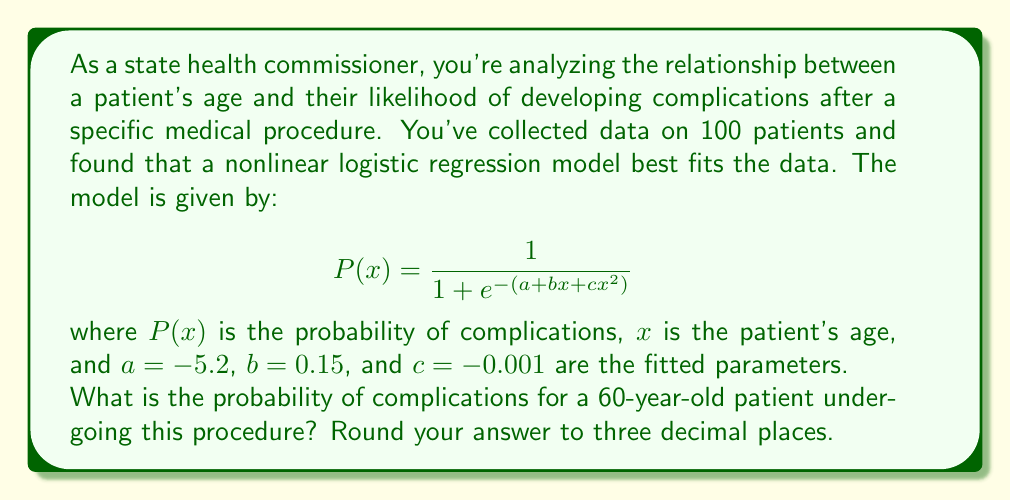Help me with this question. To solve this problem, we need to follow these steps:

1) We have the logistic regression model:
   $$ P(x) = \frac{1}{1 + e^{-(a + bx + cx^2)}} $$

2) We're given the parameter values:
   $a = -5.2$
   $b = 0.15$
   $c = -0.001$

3) We need to calculate for $x = 60$ (patient's age)

4) Let's substitute these values into the equation:
   $$ P(60) = \frac{1}{1 + e^{-(-5.2 + 0.15(60) + (-0.001)(60^2))}} $$

5) First, let's calculate the exponent:
   $-5.2 + 0.15(60) + (-0.001)(60^2)$
   $= -5.2 + 9 - 0.001(3600)$
   $= -5.2 + 9 - 3.6$
   $= 0.2$

6) Now our equation looks like:
   $$ P(60) = \frac{1}{1 + e^{-0.2}} $$

7) Calculate $e^{-0.2} ≈ 0.8187$

8) Substitute this value:
   $$ P(60) = \frac{1}{1 + 0.8187} = \frac{1}{1.8187} $$

9) Calculate the final result:
   $1 / 1.8187 ≈ 0.5498$

10) Rounding to three decimal places: 0.550
Answer: 0.550 